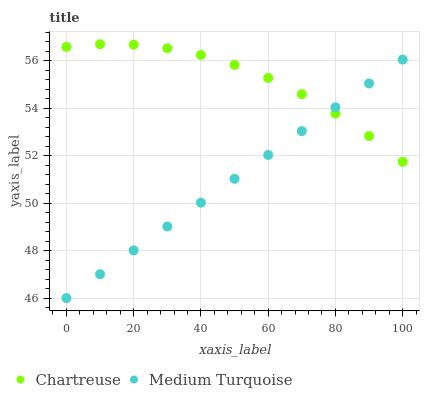Does Medium Turquoise have the minimum area under the curve?
Answer yes or no. Yes. Does Chartreuse have the maximum area under the curve?
Answer yes or no. Yes. Does Medium Turquoise have the maximum area under the curve?
Answer yes or no. No. Is Medium Turquoise the smoothest?
Answer yes or no. Yes. Is Chartreuse the roughest?
Answer yes or no. Yes. Is Medium Turquoise the roughest?
Answer yes or no. No. Does Medium Turquoise have the lowest value?
Answer yes or no. Yes. Does Chartreuse have the highest value?
Answer yes or no. Yes. Does Medium Turquoise have the highest value?
Answer yes or no. No. Does Chartreuse intersect Medium Turquoise?
Answer yes or no. Yes. Is Chartreuse less than Medium Turquoise?
Answer yes or no. No. Is Chartreuse greater than Medium Turquoise?
Answer yes or no. No. 